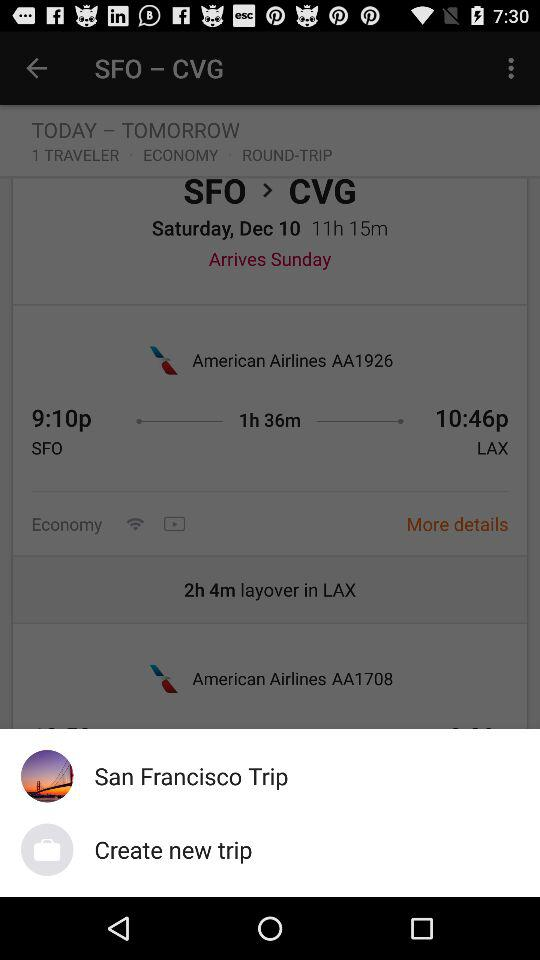What is the layover time duration? The layover time duration is 2 hours and 4 minutes. 